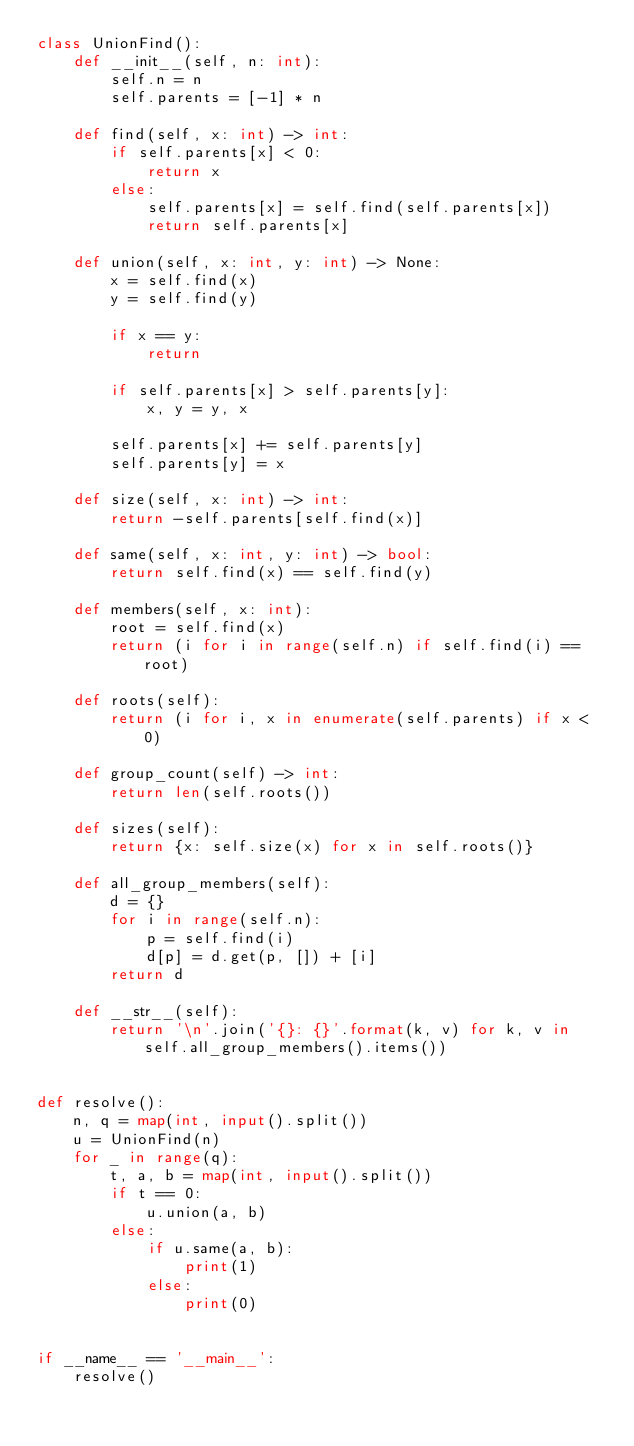<code> <loc_0><loc_0><loc_500><loc_500><_Python_>class UnionFind():
    def __init__(self, n: int):
        self.n = n
        self.parents = [-1] * n

    def find(self, x: int) -> int:
        if self.parents[x] < 0:
            return x
        else:
            self.parents[x] = self.find(self.parents[x])
            return self.parents[x]

    def union(self, x: int, y: int) -> None:
        x = self.find(x)
        y = self.find(y)

        if x == y:
            return

        if self.parents[x] > self.parents[y]:
            x, y = y, x

        self.parents[x] += self.parents[y]
        self.parents[y] = x

    def size(self, x: int) -> int:
        return -self.parents[self.find(x)]

    def same(self, x: int, y: int) -> bool:
        return self.find(x) == self.find(y)

    def members(self, x: int):
        root = self.find(x)
        return (i for i in range(self.n) if self.find(i) == root)

    def roots(self):
        return (i for i, x in enumerate(self.parents) if x < 0)

    def group_count(self) -> int:
        return len(self.roots())

    def sizes(self):
        return {x: self.size(x) for x in self.roots()}

    def all_group_members(self):
        d = {}
        for i in range(self.n):
            p = self.find(i)
            d[p] = d.get(p, []) + [i]
        return d

    def __str__(self):
        return '\n'.join('{}: {}'.format(k, v) for k, v in self.all_group_members().items())


def resolve():
    n, q = map(int, input().split())
    u = UnionFind(n)
    for _ in range(q):
        t, a, b = map(int, input().split())
        if t == 0:
            u.union(a, b)
        else:
            if u.same(a, b):
                print(1)
            else:
                print(0)


if __name__ == '__main__':
    resolve()
</code> 